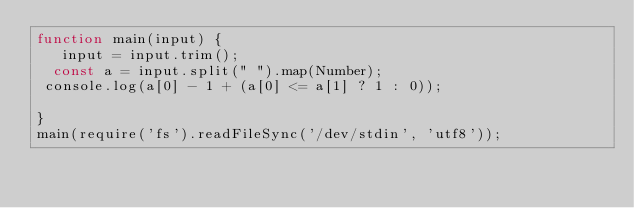<code> <loc_0><loc_0><loc_500><loc_500><_JavaScript_>function main(input) {
   input = input.trim();
  const a = input.split(" ").map(Number);
 console.log(a[0] - 1 + (a[0] <= a[1] ? 1 : 0));

}
main(require('fs').readFileSync('/dev/stdin', 'utf8'));
</code> 